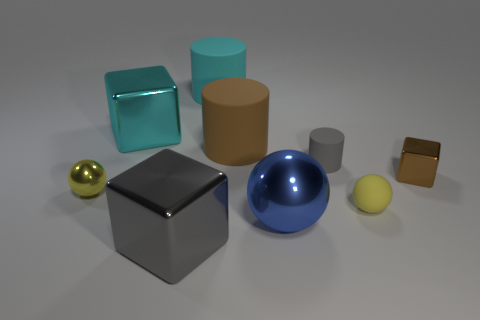Subtract 1 cylinders. How many cylinders are left? 2 Subtract all large cylinders. How many cylinders are left? 1 Subtract all yellow cubes. How many yellow balls are left? 2 Subtract all spheres. How many objects are left? 6 Subtract all big brown matte cylinders. Subtract all gray cubes. How many objects are left? 7 Add 1 yellow balls. How many yellow balls are left? 3 Add 3 small green blocks. How many small green blocks exist? 3 Subtract 0 blue cylinders. How many objects are left? 9 